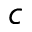Convert formula to latex. <formula><loc_0><loc_0><loc_500><loc_500>c</formula> 